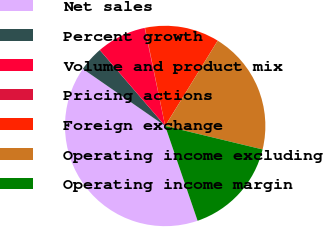<chart> <loc_0><loc_0><loc_500><loc_500><pie_chart><fcel>Net sales<fcel>Percent growth<fcel>Volume and product mix<fcel>Pricing actions<fcel>Foreign exchange<fcel>Operating income excluding<fcel>Operating income margin<nl><fcel>39.89%<fcel>4.04%<fcel>8.03%<fcel>0.06%<fcel>12.01%<fcel>19.98%<fcel>15.99%<nl></chart> 